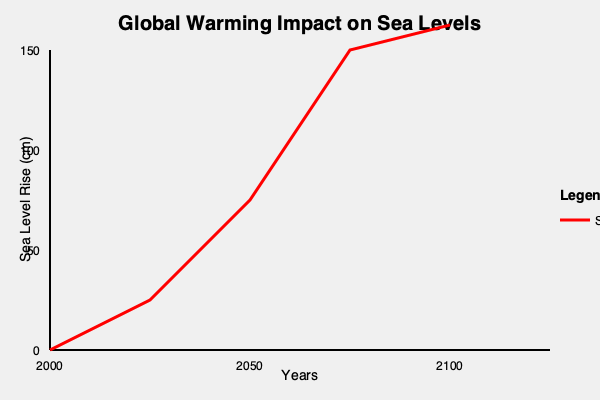As a news anchor discussing the consequences of misinformation, what is the most significant misleading element in this infographic about sea level rise due to global warming? To identify the most significant misleading element in this infographic, let's analyze it step-by-step:

1. Title and Topic: The graph is titled "Global Warming Impact on Sea Levels," which is a current and relevant topic.

2. Axes and Labels: The x-axis represents years from 2000 to 2100, and the y-axis shows sea level rise in centimeters. This is appropriate for the topic.

3. Data Representation: The red line represents sea level rise over time. This is where the main issue lies:

   a. The line shows an exponential increase in sea level rise, which is not supported by current scientific consensus.
   b. The graph suggests a rise of about 150 cm (1.5 meters) by 2100, which is significantly higher than most scientific projections.
   c. The curve's shape implies an extreme acceleration in sea level rise, especially between 2050 and 2100, which is not consistent with current models.

4. Scale: The y-axis scale is appropriate, but the extreme curve makes the rise appear more dramatic than it likely would be.

5. Missing Information: There's no indication of the data source or methodology used to create this projection.

6. Context: The graph lacks context about different scenarios or ranges of projections, presenting only one extreme outcome.

The most significant misleading element is the exaggerated and unsupported projection of sea level rise, particularly the extreme acceleration shown between 2050 and 2100. This could lead to unnecessary panic and mistrust in climate science when actual observations don't match this dramatic prediction.
Answer: Exaggerated sea level rise projection 